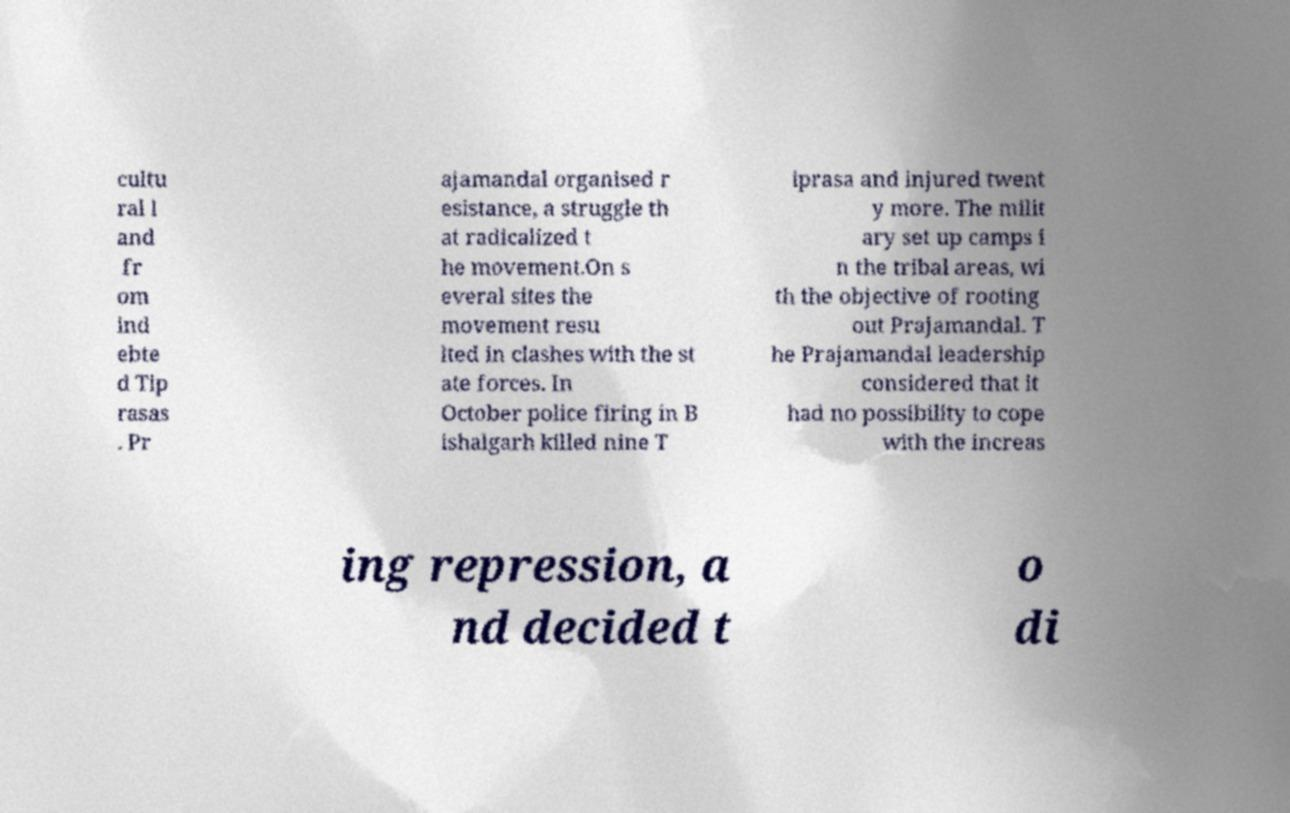What messages or text are displayed in this image? I need them in a readable, typed format. cultu ral l and fr om ind ebte d Tip rasas . Pr ajamandal organised r esistance, a struggle th at radicalized t he movement.On s everal sites the movement resu lted in clashes with the st ate forces. In October police firing in B ishalgarh killed nine T iprasa and injured twent y more. The milit ary set up camps i n the tribal areas, wi th the objective of rooting out Prajamandal. T he Prajamandal leadership considered that it had no possibility to cope with the increas ing repression, a nd decided t o di 